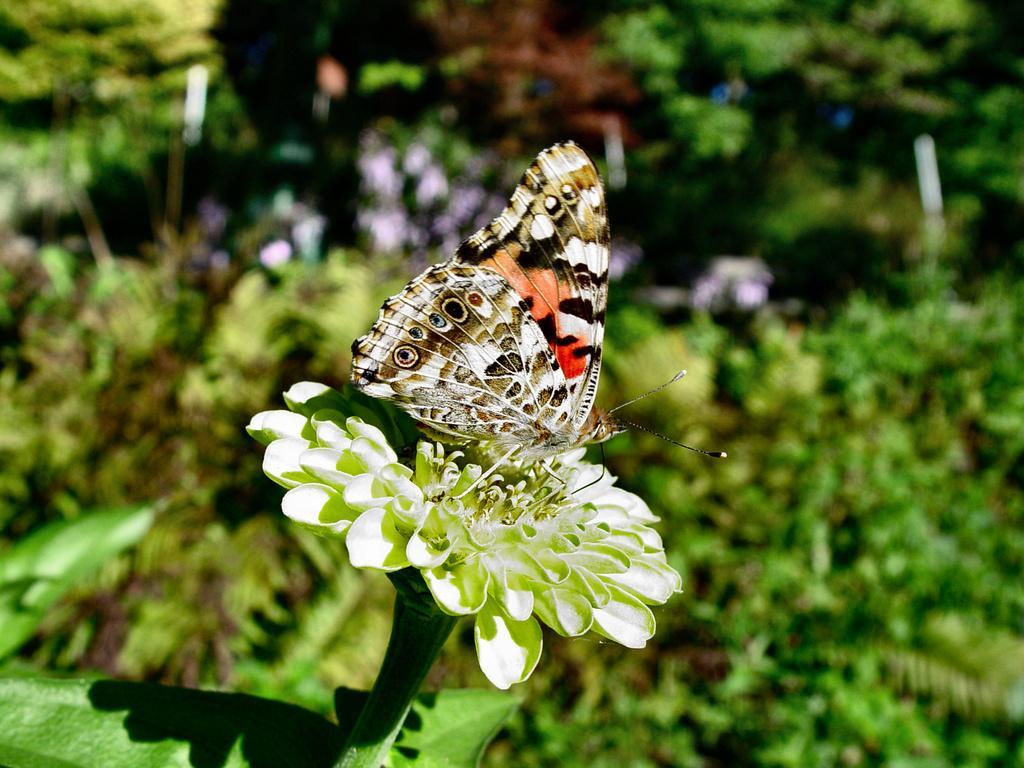In one or two sentences, can you explain what this image depicts? In this picture I can see a butterfly on the flower, behind there are some trees and plants. 